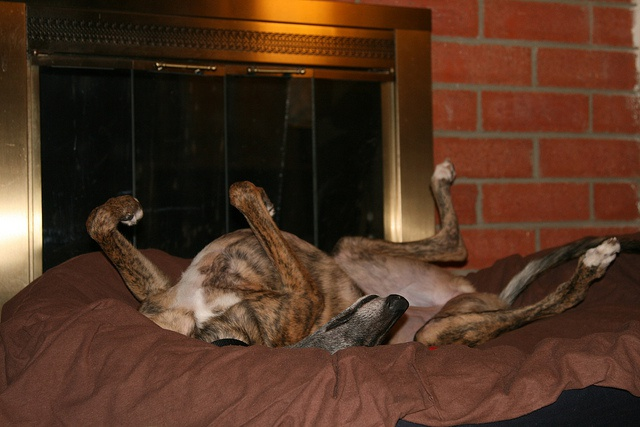Describe the objects in this image and their specific colors. I can see bed in black, maroon, and brown tones and dog in black, maroon, and gray tones in this image. 